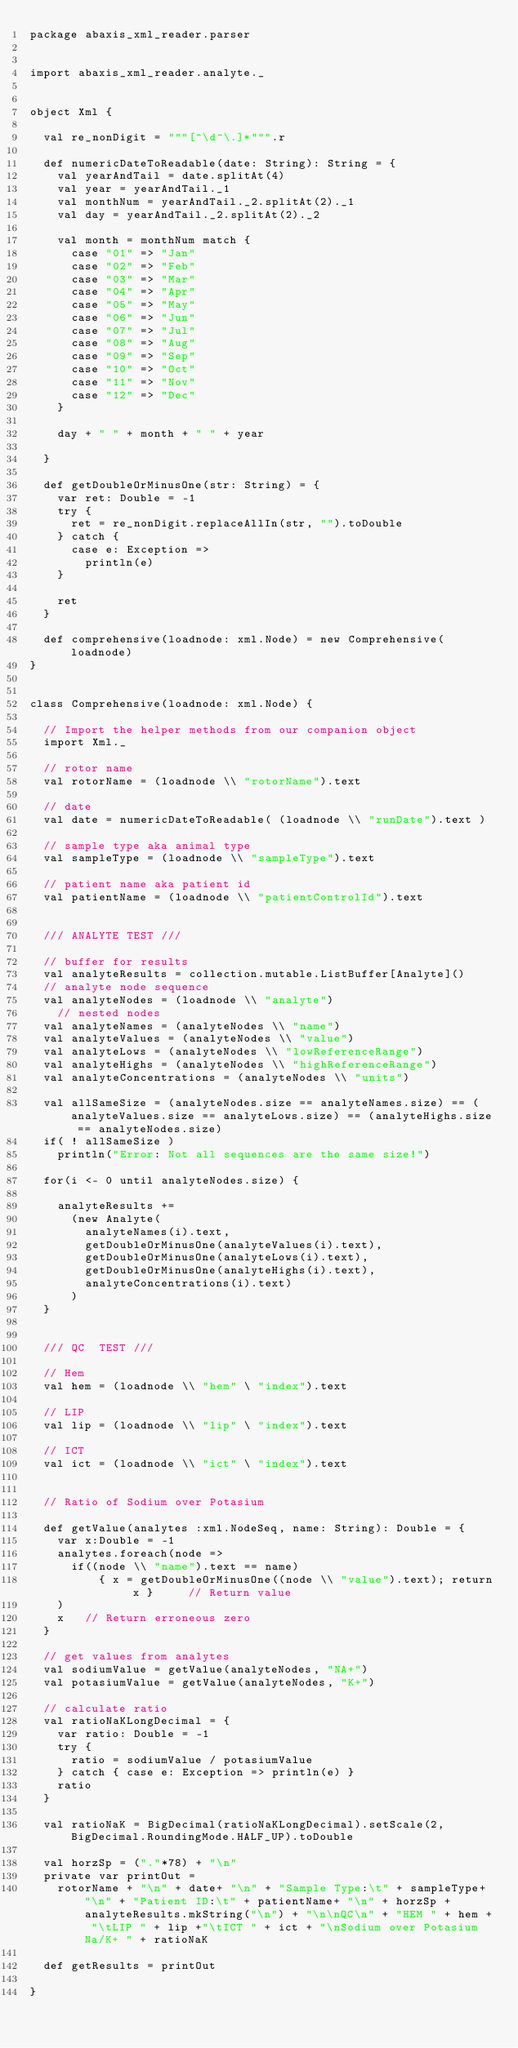Convert code to text. <code><loc_0><loc_0><loc_500><loc_500><_Scala_>package abaxis_xml_reader.parser


import abaxis_xml_reader.analyte._


object Xml {

  val re_nonDigit = """[^\d^\.]*""".r

  def numericDateToReadable(date: String): String = { 
    val yearAndTail = date.splitAt(4)
    val year = yearAndTail._1
    val monthNum = yearAndTail._2.splitAt(2)._1
    val day = yearAndTail._2.splitAt(2)._2

    val month = monthNum match {
      case "01" => "Jan"
      case "02" => "Feb"
      case "03" => "Mar"
      case "04" => "Apr"
      case "05" => "May"
      case "06" => "Jun"
      case "07" => "Jul"
      case "08" => "Aug"
      case "09" => "Sep"
      case "10" => "Oct"
      case "11" => "Nov"
      case "12" => "Dec"
    }

    day + " " + month + " " + year

  }

  def getDoubleOrMinusOne(str: String) = {
    var ret: Double = -1
    try {
      ret = re_nonDigit.replaceAllIn(str, "").toDouble
    } catch {
      case e: Exception => 
        println(e)
    }

    ret
  }

  def comprehensive(loadnode: xml.Node) = new Comprehensive(loadnode)
}


class Comprehensive(loadnode: xml.Node) {

  // Import the helper methods from our companion object
  import Xml._

  // rotor name
  val rotorName = (loadnode \\ "rotorName").text

  // date
  val date = numericDateToReadable( (loadnode \\ "runDate").text )

  // sample type aka animal type 
  val sampleType = (loadnode \\ "sampleType").text

  // patient name aka patient id
  val patientName = (loadnode \\ "patientControlId").text


  /// ANALYTE TEST ///

  // buffer for results 
  val analyteResults = collection.mutable.ListBuffer[Analyte]()
  // analyte node sequence
  val analyteNodes = (loadnode \\ "analyte")
    // nested nodes
  val analyteNames = (analyteNodes \\ "name")
  val analyteValues = (analyteNodes \\ "value")
  val analyteLows = (analyteNodes \\ "lowReferenceRange")
  val analyteHighs = (analyteNodes \\ "highReferenceRange")
  val analyteConcentrations = (analyteNodes \\ "units")

  val allSameSize = (analyteNodes.size == analyteNames.size) == (analyteValues.size == analyteLows.size) == (analyteHighs.size == analyteNodes.size)
  if( ! allSameSize ) 
    println("Error: Not all sequences are the same size!")

  for(i <- 0 until analyteNodes.size) {

    analyteResults += 
      (new Analyte(
        analyteNames(i).text,
        getDoubleOrMinusOne(analyteValues(i).text),
        getDoubleOrMinusOne(analyteLows(i).text),
        getDoubleOrMinusOne(analyteHighs(i).text),
        analyteConcentrations(i).text)
      )
  }


  /// QC  TEST ///

  // Hem
  val hem = (loadnode \\ "hem" \ "index").text

  // LIP 
  val lip = (loadnode \\ "lip" \ "index").text

  // ICT
  val ict = (loadnode \\ "ict" \ "index").text


  // Ratio of Sodium over Potasium 

  def getValue(analytes :xml.NodeSeq, name: String): Double = {
    var x:Double = -1 
    analytes.foreach(node => 
      if((node \\ "name").text == name) 
          { x = getDoubleOrMinusOne((node \\ "value").text); return x }     // Return value
    )
    x   // Return erroneous zero
  }

  // get values from analytes 
  val sodiumValue = getValue(analyteNodes, "NA+")
  val potasiumValue = getValue(analyteNodes, "K+")

  // calculate ratio
  val ratioNaKLongDecimal = {
    var ratio: Double = -1 
    try {
      ratio = sodiumValue / potasiumValue
    } catch { case e: Exception => println(e) }
    ratio
  }

  val ratioNaK = BigDecimal(ratioNaKLongDecimal).setScale(2, BigDecimal.RoundingMode.HALF_UP).toDouble

  val horzSp = ("."*78) + "\n"
  private var printOut =
    rotorName + "\n" + date+ "\n" + "Sample Type:\t" + sampleType+ "\n" + "Patient ID:\t" + patientName+ "\n" + horzSp + analyteResults.mkString("\n") + "\n\nQC\n" + "HEM " + hem + "\tLIP " + lip +"\tICT " + ict + "\nSodium over Potasium Na/K+ " + ratioNaK

  def getResults = printOut
  
}
</code> 